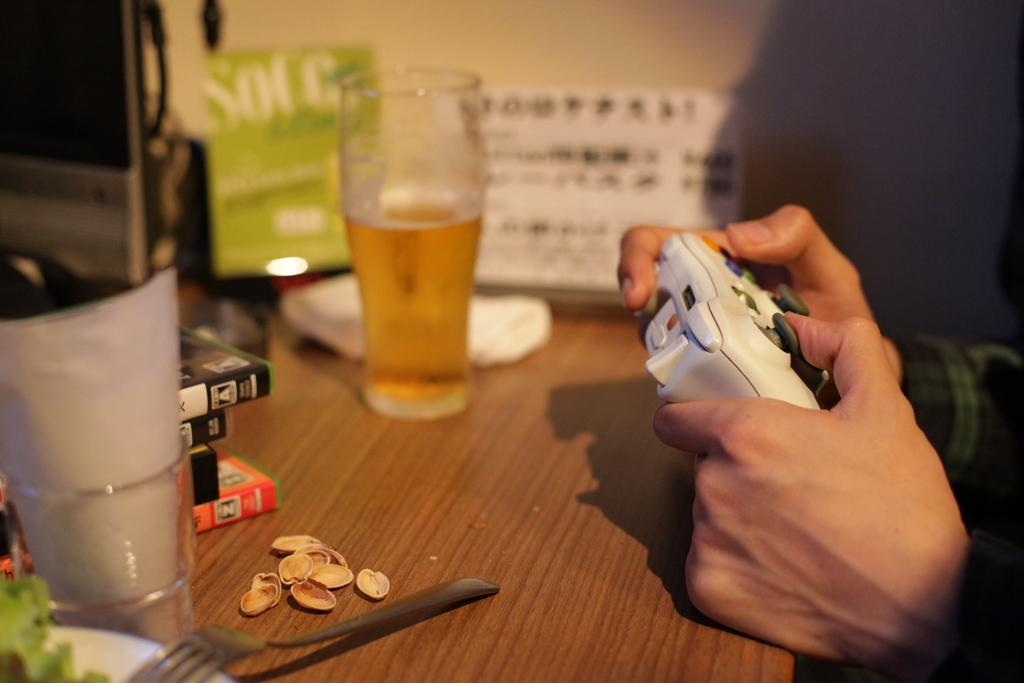What is the person in the image holding? The person is holding a joystick in the image. What type of beverage is in the glass in the image? There is a glass half filled with wine in the image. What items can be seen related to reading or learning in the image? There are books visible in the image. What utensil is present in the image? There is a spoon in the image. What type of food is visible in the image? There are dry fruits in the image. What type of dress is the person wearing in the image? The provided facts do not mention any dress or clothing worn by the person in the image. 